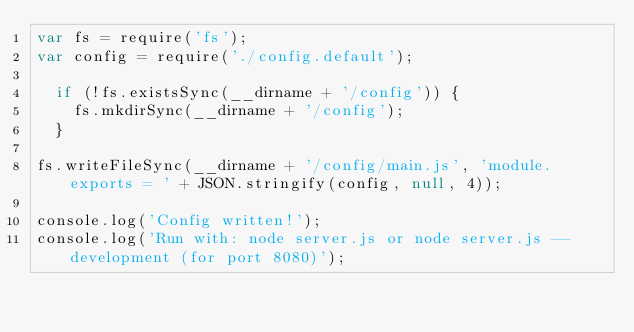Convert code to text. <code><loc_0><loc_0><loc_500><loc_500><_JavaScript_>var fs = require('fs');
var config = require('./config.default');

  if (!fs.existsSync(__dirname + '/config')) {
    fs.mkdirSync(__dirname + '/config');
  }

fs.writeFileSync(__dirname + '/config/main.js', 'module.exports = ' + JSON.stringify(config, null, 4));

console.log('Config written!');
console.log('Run with: node server.js or node server.js --development (for port 8080)');</code> 